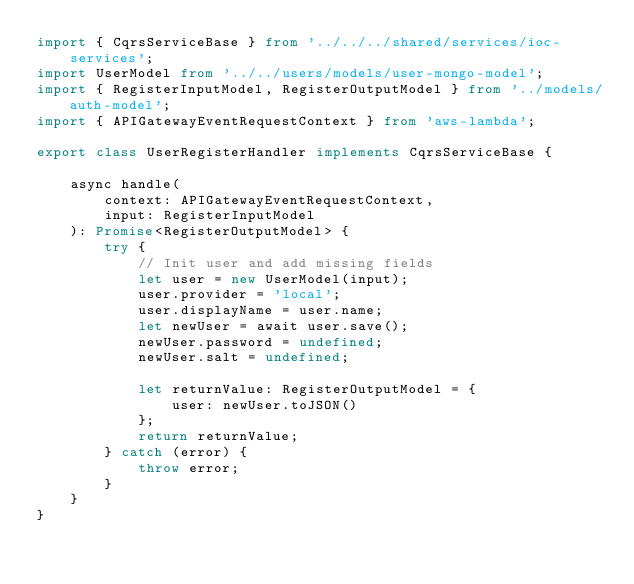<code> <loc_0><loc_0><loc_500><loc_500><_TypeScript_>import { CqrsServiceBase } from '../../../shared/services/ioc-services';
import UserModel from '../../users/models/user-mongo-model';
import { RegisterInputModel, RegisterOutputModel } from '../models/auth-model';
import { APIGatewayEventRequestContext } from 'aws-lambda';

export class UserRegisterHandler implements CqrsServiceBase {

    async handle(
        context: APIGatewayEventRequestContext,
        input: RegisterInputModel
    ): Promise<RegisterOutputModel> {
        try {
            // Init user and add missing fields
            let user = new UserModel(input);
            user.provider = 'local';
            user.displayName = user.name;
            let newUser = await user.save();
            newUser.password = undefined;
            newUser.salt = undefined;

            let returnValue: RegisterOutputModel = {
                user: newUser.toJSON()
            };
            return returnValue;
        } catch (error) {
            throw error;
        }
    }
}
</code> 